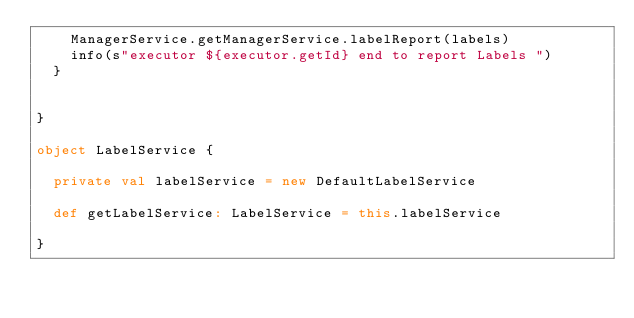Convert code to text. <code><loc_0><loc_0><loc_500><loc_500><_Scala_>    ManagerService.getManagerService.labelReport(labels)
    info(s"executor ${executor.getId} end to report Labels ")
  }


}

object LabelService {

  private val labelService = new DefaultLabelService

  def getLabelService: LabelService = this.labelService

}</code> 